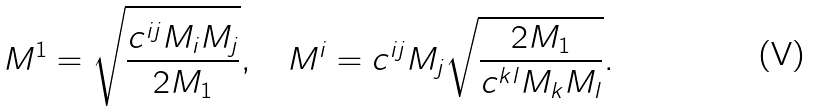<formula> <loc_0><loc_0><loc_500><loc_500>M ^ { 1 } = \sqrt { \frac { c ^ { i j } M _ { i } M _ { j } } { 2 M _ { 1 } } } , \quad M ^ { i } = c ^ { i j } M _ { j } \sqrt { \frac { 2 M _ { 1 } } { c ^ { k l } M _ { k } M _ { l } } } .</formula> 